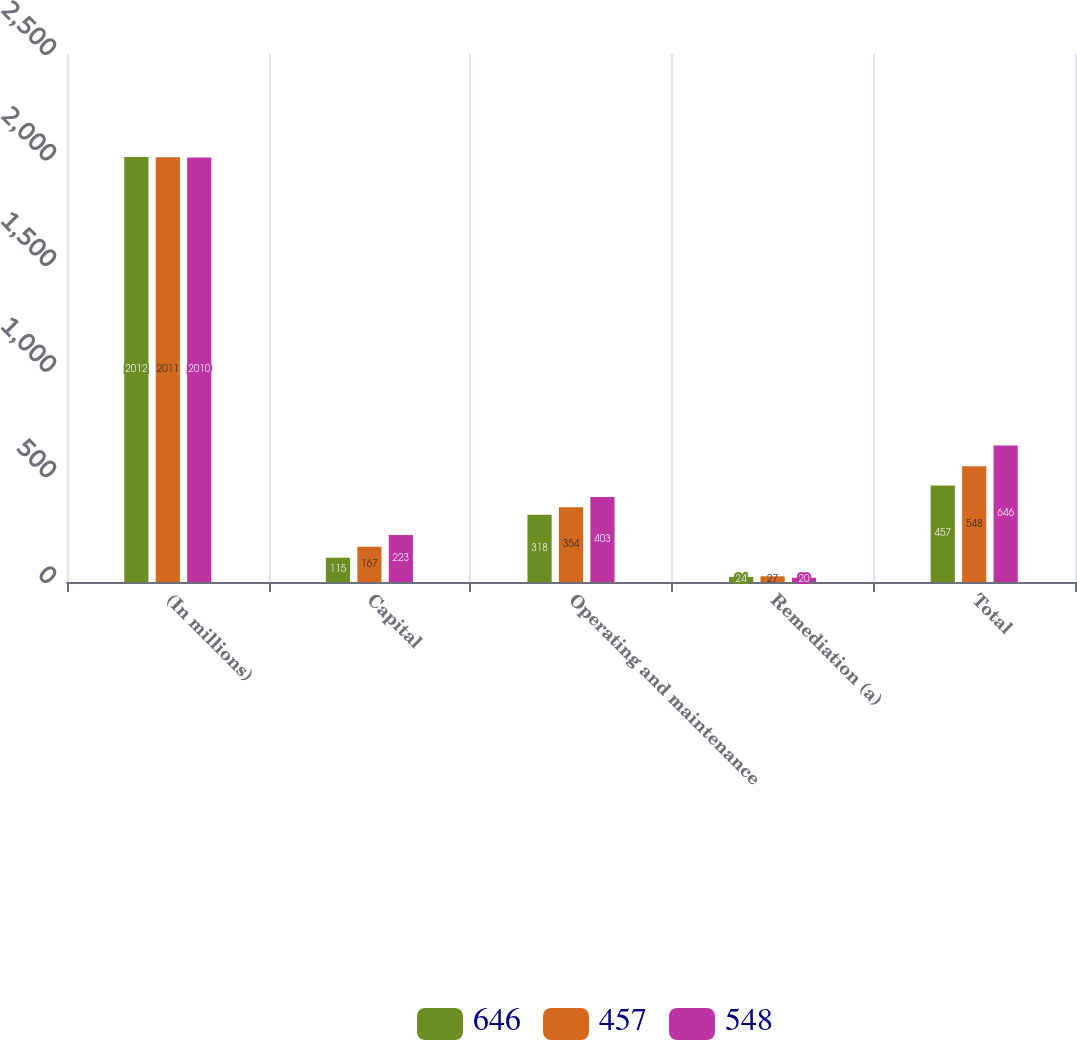<chart> <loc_0><loc_0><loc_500><loc_500><stacked_bar_chart><ecel><fcel>(In millions)<fcel>Capital<fcel>Operating and maintenance<fcel>Remediation (a)<fcel>Total<nl><fcel>646<fcel>2012<fcel>115<fcel>318<fcel>24<fcel>457<nl><fcel>457<fcel>2011<fcel>167<fcel>354<fcel>27<fcel>548<nl><fcel>548<fcel>2010<fcel>223<fcel>403<fcel>20<fcel>646<nl></chart> 